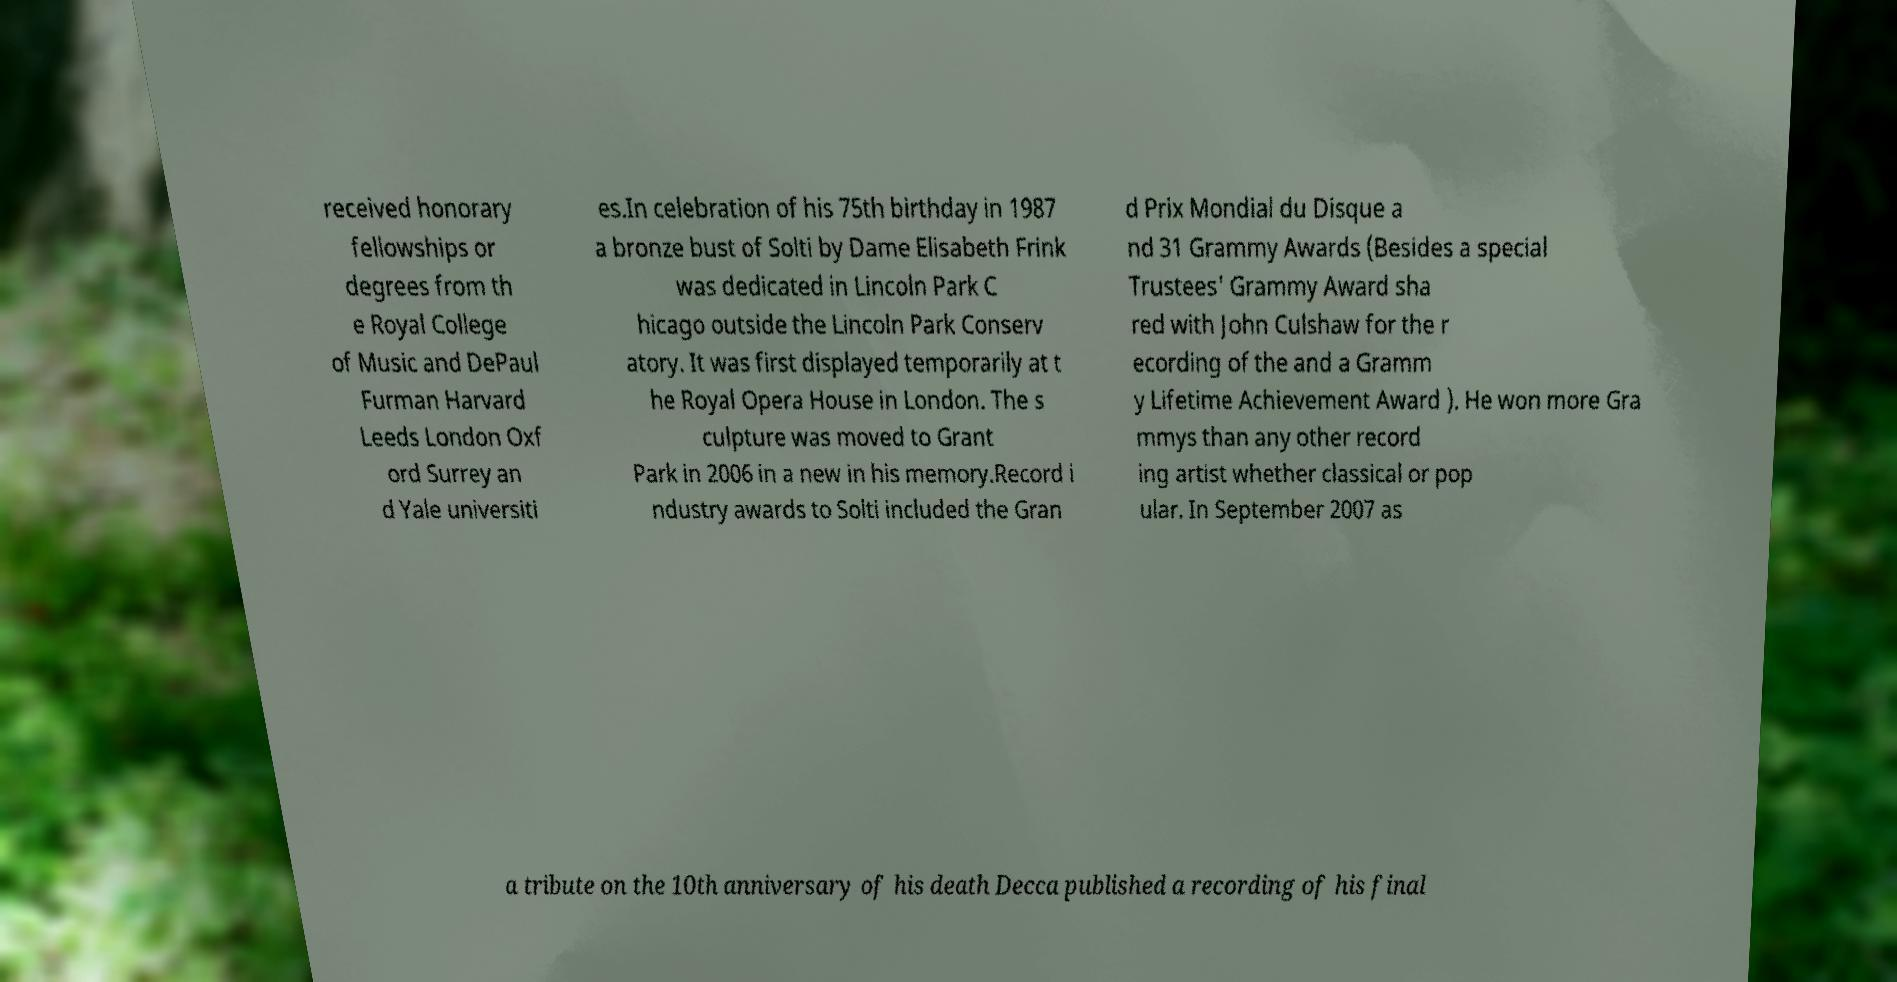Can you accurately transcribe the text from the provided image for me? received honorary fellowships or degrees from th e Royal College of Music and DePaul Furman Harvard Leeds London Oxf ord Surrey an d Yale universiti es.In celebration of his 75th birthday in 1987 a bronze bust of Solti by Dame Elisabeth Frink was dedicated in Lincoln Park C hicago outside the Lincoln Park Conserv atory. It was first displayed temporarily at t he Royal Opera House in London. The s culpture was moved to Grant Park in 2006 in a new in his memory.Record i ndustry awards to Solti included the Gran d Prix Mondial du Disque a nd 31 Grammy Awards (Besides a special Trustees' Grammy Award sha red with John Culshaw for the r ecording of the and a Gramm y Lifetime Achievement Award ). He won more Gra mmys than any other record ing artist whether classical or pop ular. In September 2007 as a tribute on the 10th anniversary of his death Decca published a recording of his final 